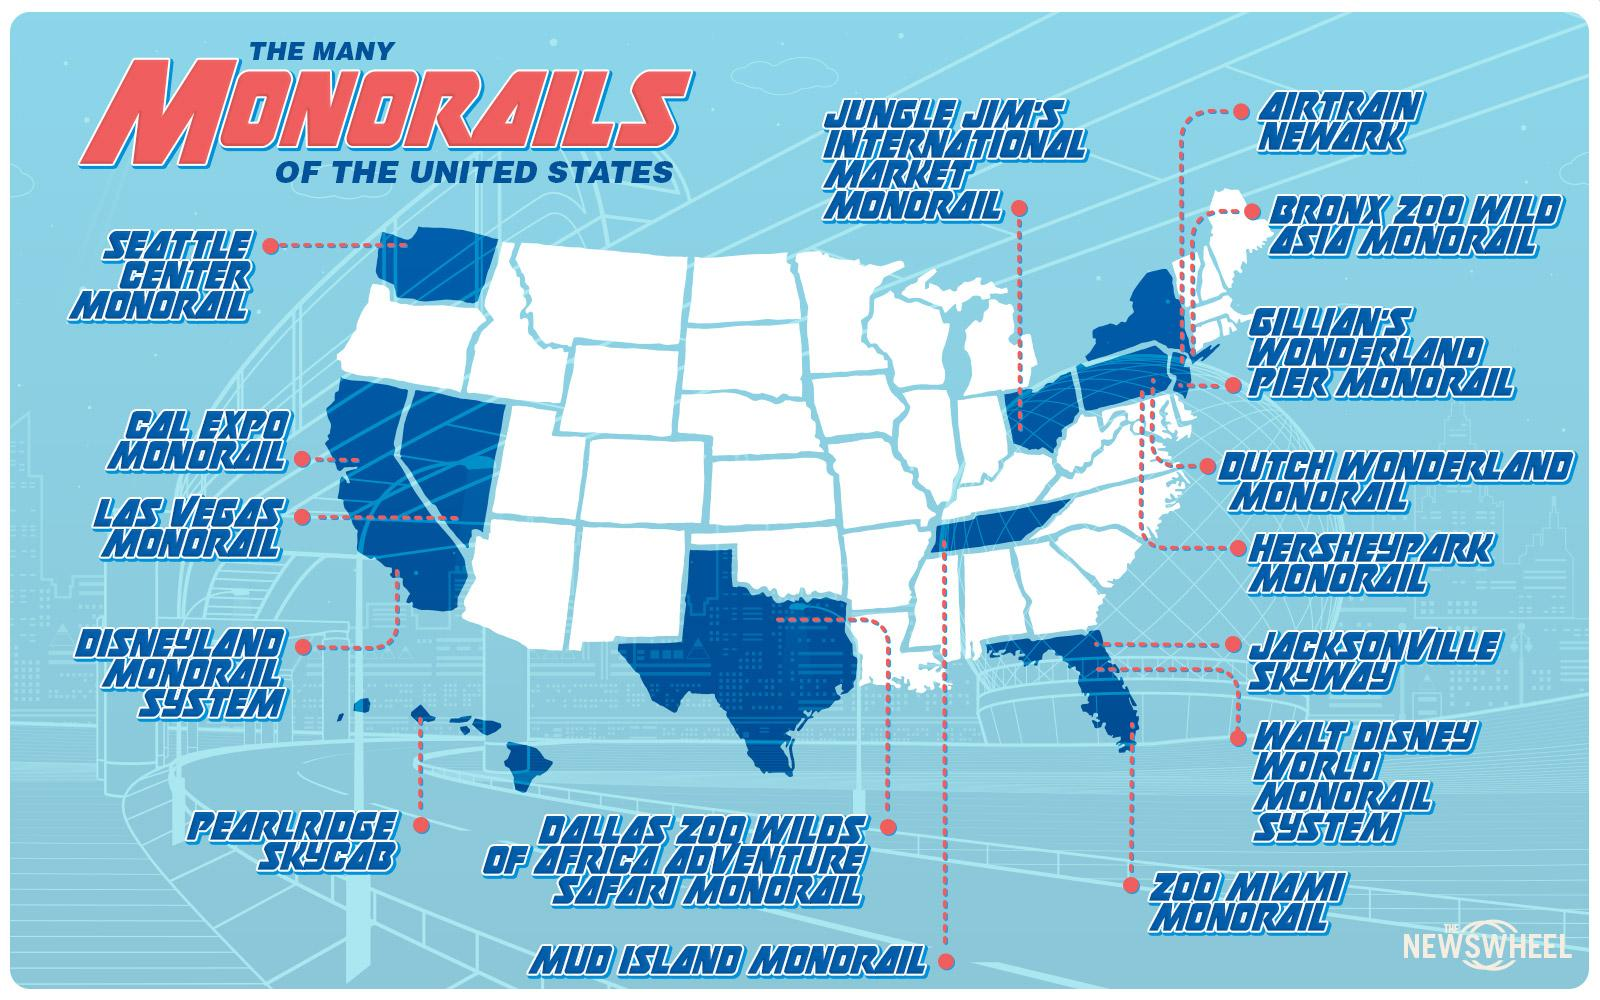Draw attention to some important aspects in this diagram. The name of the monorail located in the islands of the United States is Pearlridge Skycab. The Bronx Zoo Wild Asia Monorail, located in the extreme eastern region of the United States, is its namesake. There are 16 monorails in America. The Seattle Center Monorail is located in the Northwest region of the United States. 